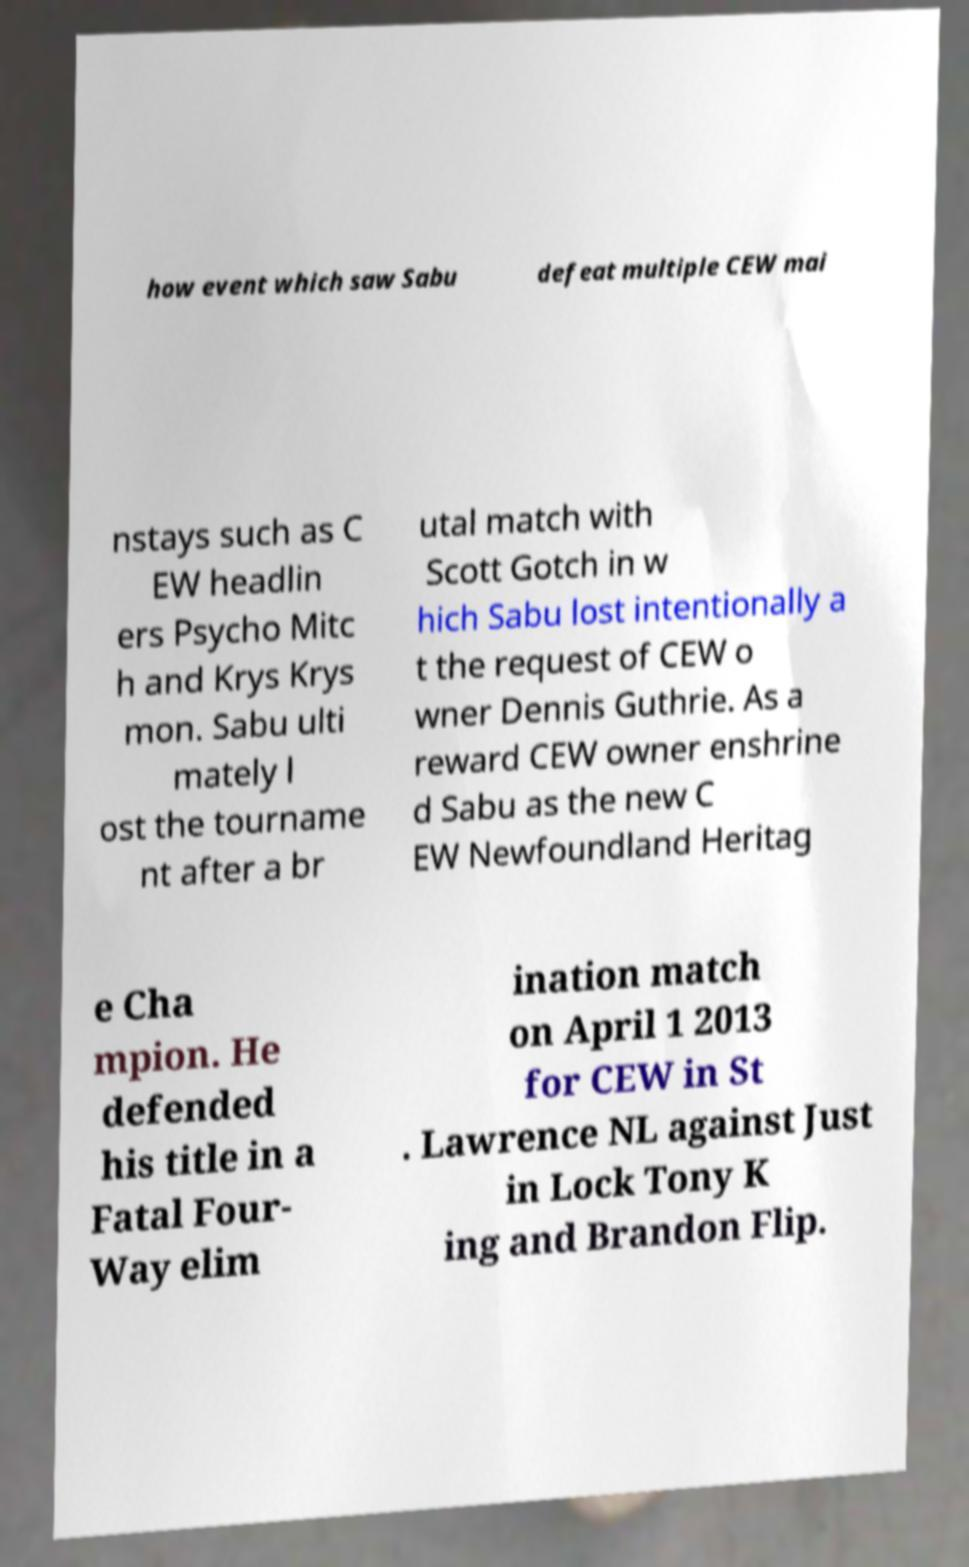Could you extract and type out the text from this image? how event which saw Sabu defeat multiple CEW mai nstays such as C EW headlin ers Psycho Mitc h and Krys Krys mon. Sabu ulti mately l ost the tourname nt after a br utal match with Scott Gotch in w hich Sabu lost intentionally a t the request of CEW o wner Dennis Guthrie. As a reward CEW owner enshrine d Sabu as the new C EW Newfoundland Heritag e Cha mpion. He defended his title in a Fatal Four- Way elim ination match on April 1 2013 for CEW in St . Lawrence NL against Just in Lock Tony K ing and Brandon Flip. 